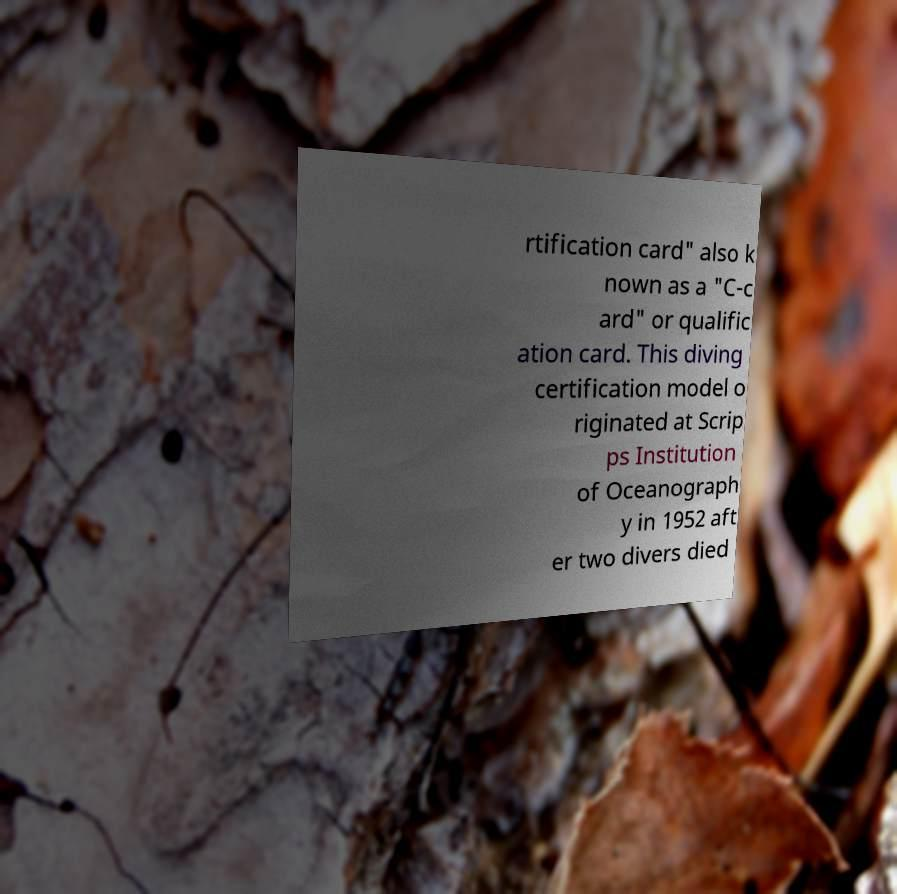There's text embedded in this image that I need extracted. Can you transcribe it verbatim? rtification card" also k nown as a "C-c ard" or qualific ation card. This diving certification model o riginated at Scrip ps Institution of Oceanograph y in 1952 aft er two divers died 